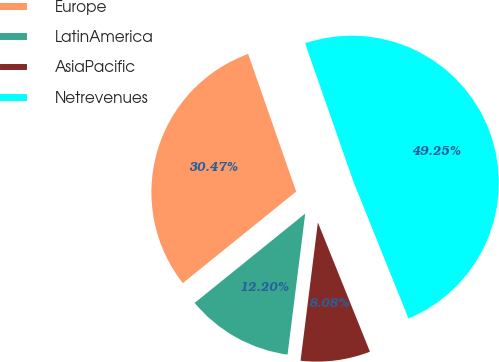Convert chart. <chart><loc_0><loc_0><loc_500><loc_500><pie_chart><fcel>Europe<fcel>LatinAmerica<fcel>AsiaPacific<fcel>Netrevenues<nl><fcel>30.47%<fcel>12.2%<fcel>8.08%<fcel>49.25%<nl></chart> 